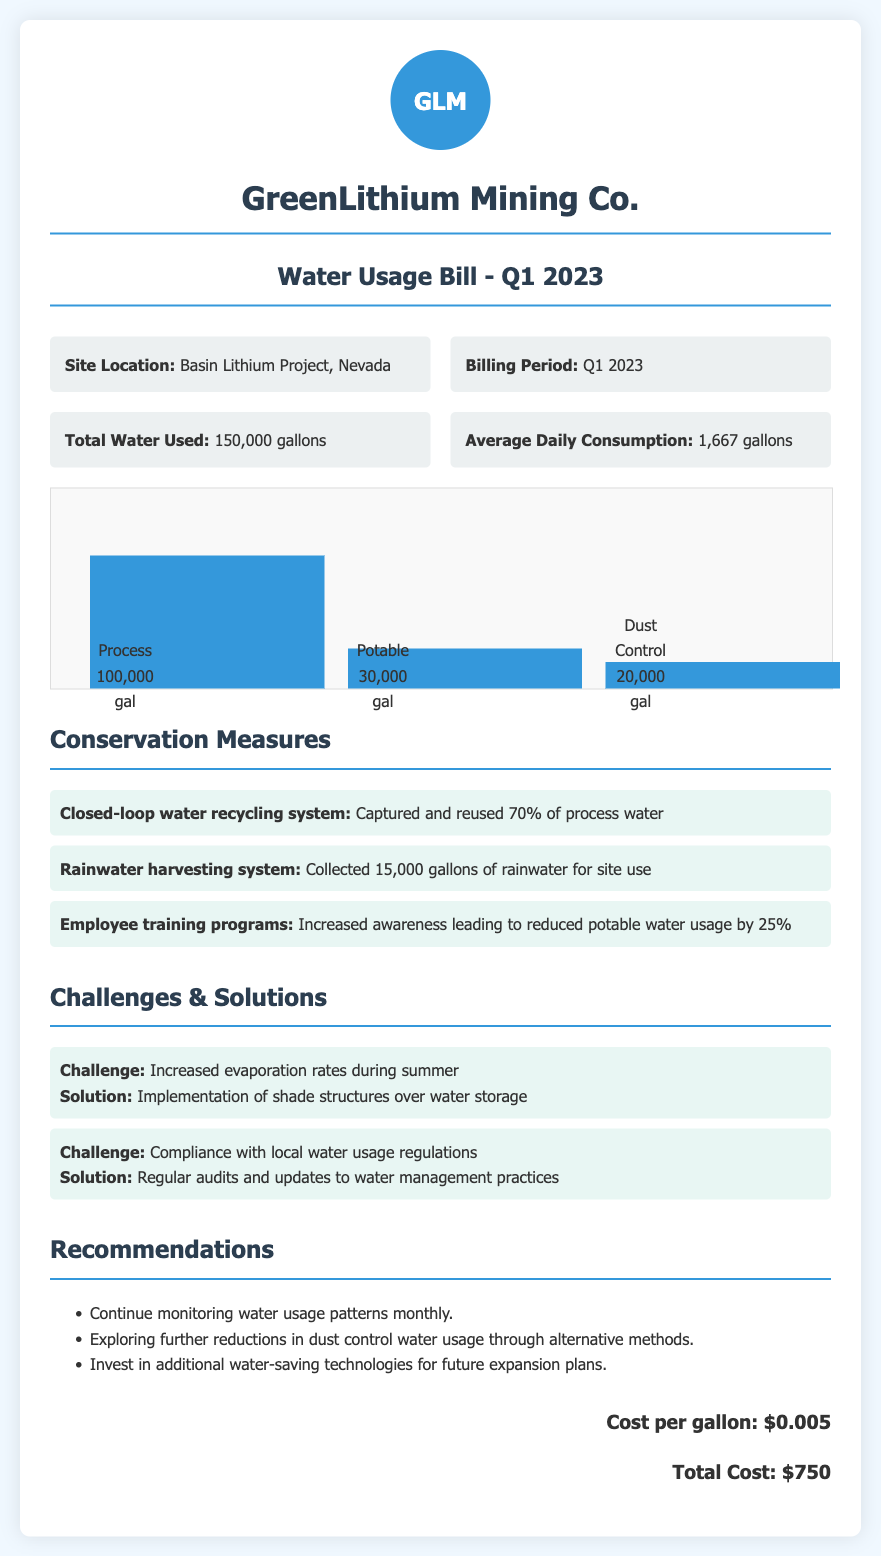what is the total water used? The document states that the total water used in Q1 2023 is 150,000 gallons.
Answer: 150,000 gallons what is the average daily consumption? The document mentions that the average daily consumption is calculated at 1,667 gallons.
Answer: 1,667 gallons how much water was used for Process? According to the chart, 100,000 gallons were used for Process.
Answer: 100,000 gal what conservation measure collected 15,000 gallons of water? The document highlights the rainwater harvesting system which collected 15,000 gallons.
Answer: Rainwater harvesting system what percentage of process water was reused? The document indicates that 70% of process water was captured and reused.
Answer: 70% what was the total cost for water usage? The document lists the total cost for water usage as $750.
Answer: $750 what challenge was related to increased evaporation? A challenge mentioned in the document pertains to increased evaporation rates during summer.
Answer: Increased evaporation rates during summer what is one recommendation made in the document? One of the recommendations is to continue monitoring water usage patterns monthly.
Answer: Continue monitoring water usage patterns monthly which location is specified for the water usage bill? The document specifies the site location as the Basin Lithium Project, Nevada.
Answer: Basin Lithium Project, Nevada 